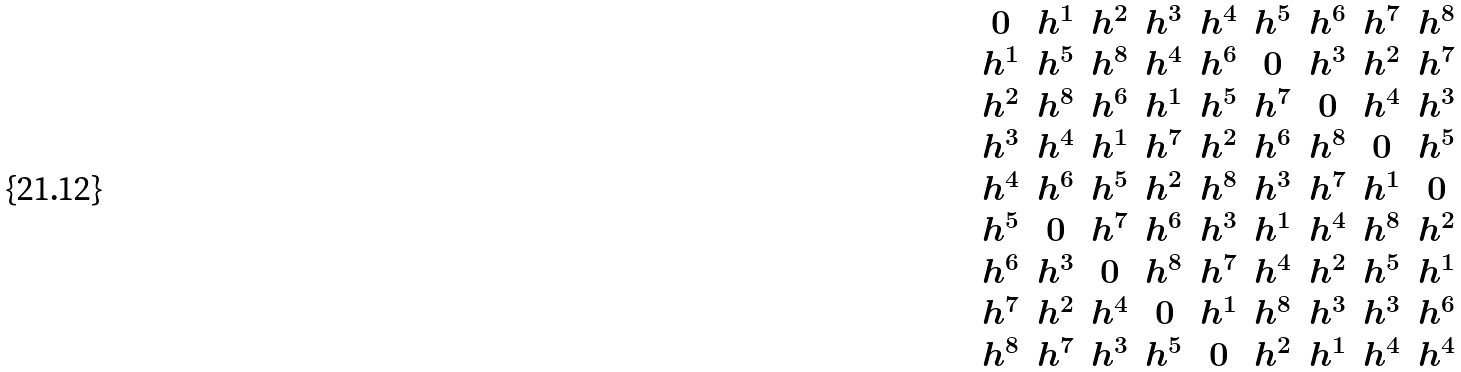Convert formula to latex. <formula><loc_0><loc_0><loc_500><loc_500>\begin{array} { c c c c c c c c c } 0 & h ^ { 1 } & h ^ { 2 } & h ^ { 3 } & h ^ { 4 } & h ^ { 5 } & h ^ { 6 } & h ^ { 7 } & h ^ { 8 } \\ h ^ { 1 } & h ^ { 5 } & h ^ { 8 } & h ^ { 4 } & h ^ { 6 } & 0 & h ^ { 3 } & h ^ { 2 } & h ^ { 7 } \\ h ^ { 2 } & h ^ { 8 } & h ^ { 6 } & h ^ { 1 } & h ^ { 5 } & h ^ { 7 } & 0 & h ^ { 4 } & h ^ { 3 } \\ h ^ { 3 } & h ^ { 4 } & h ^ { 1 } & h ^ { 7 } & h ^ { 2 } & h ^ { 6 } & h ^ { 8 } & 0 & h ^ { 5 } \\ h ^ { 4 } & h ^ { 6 } & h ^ { 5 } & h ^ { 2 } & h ^ { 8 } & h ^ { 3 } & h ^ { 7 } & h ^ { 1 } & 0 \\ h ^ { 5 } & 0 & h ^ { 7 } & h ^ { 6 } & h ^ { 3 } & h ^ { 1 } & h ^ { 4 } & h ^ { 8 } & h ^ { 2 } \\ h ^ { 6 } & h ^ { 3 } & 0 & h ^ { 8 } & h ^ { 7 } & h ^ { 4 } & h ^ { 2 } & h ^ { 5 } & h ^ { 1 } \\ h ^ { 7 } & h ^ { 2 } & h ^ { 4 } & 0 & h ^ { 1 } & h ^ { 8 } & h ^ { 3 } & h ^ { 3 } & h ^ { 6 } \\ h ^ { 8 } & h ^ { 7 } & h ^ { 3 } & h ^ { 5 } & 0 & h ^ { 2 } & h ^ { 1 } & h ^ { 4 } & h ^ { 4 } \end{array}</formula> 